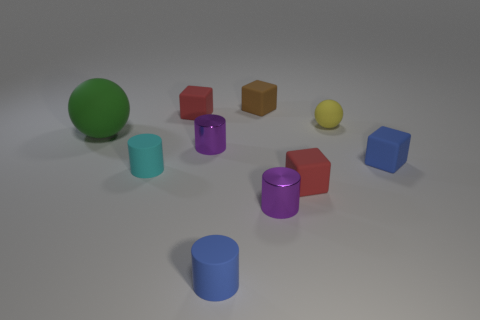Subtract 1 cylinders. How many cylinders are left? 3 Subtract all cyan balls. Subtract all purple cylinders. How many balls are left? 2 Subtract all cubes. How many objects are left? 6 Add 9 blue cylinders. How many blue cylinders exist? 10 Subtract 0 cyan blocks. How many objects are left? 10 Subtract all big green rubber cylinders. Subtract all big green objects. How many objects are left? 9 Add 6 tiny cyan rubber things. How many tiny cyan rubber things are left? 7 